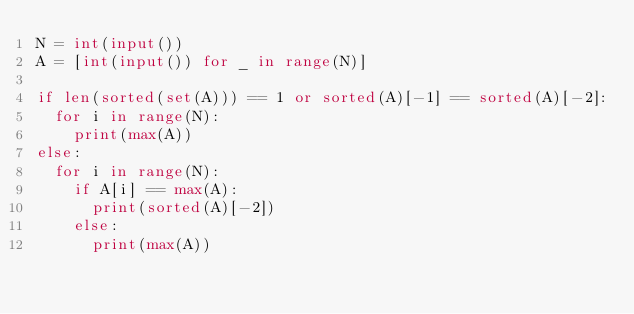<code> <loc_0><loc_0><loc_500><loc_500><_Python_>N = int(input())
A = [int(input()) for _ in range(N)]

if len(sorted(set(A))) == 1 or sorted(A)[-1] == sorted(A)[-2]:
  for i in range(N):
    print(max(A))
else:
  for i in range(N):
    if A[i] == max(A):
      print(sorted(A)[-2])
    else:
      print(max(A))</code> 